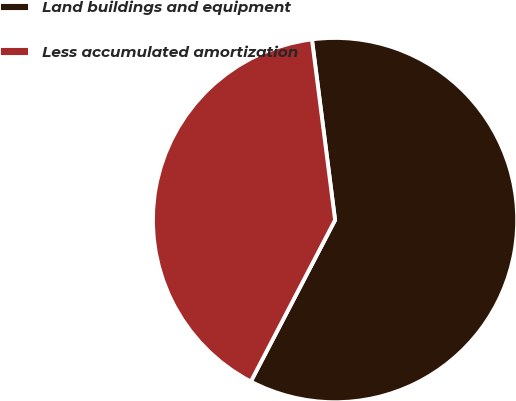Convert chart to OTSL. <chart><loc_0><loc_0><loc_500><loc_500><pie_chart><fcel>Land buildings and equipment<fcel>Less accumulated amortization<nl><fcel>59.68%<fcel>40.32%<nl></chart> 